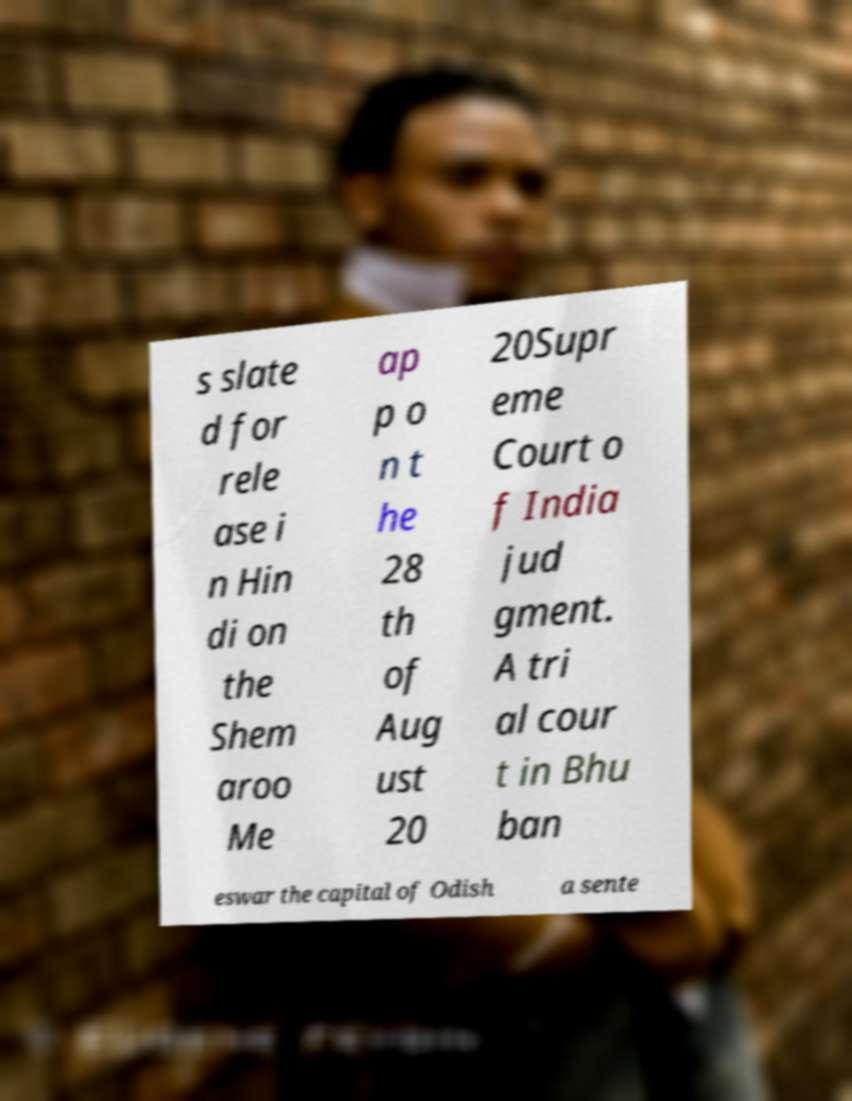Please identify and transcribe the text found in this image. s slate d for rele ase i n Hin di on the Shem aroo Me ap p o n t he 28 th of Aug ust 20 20Supr eme Court o f India jud gment. A tri al cour t in Bhu ban eswar the capital of Odish a sente 